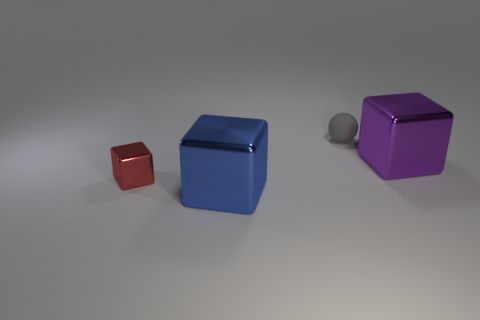Add 4 metallic blocks. How many objects exist? 8 Subtract all cubes. How many objects are left? 1 Add 4 small gray spheres. How many small gray spheres exist? 5 Subtract 1 blue blocks. How many objects are left? 3 Subtract all tiny gray rubber cylinders. Subtract all gray balls. How many objects are left? 3 Add 4 purple metal blocks. How many purple metal blocks are left? 5 